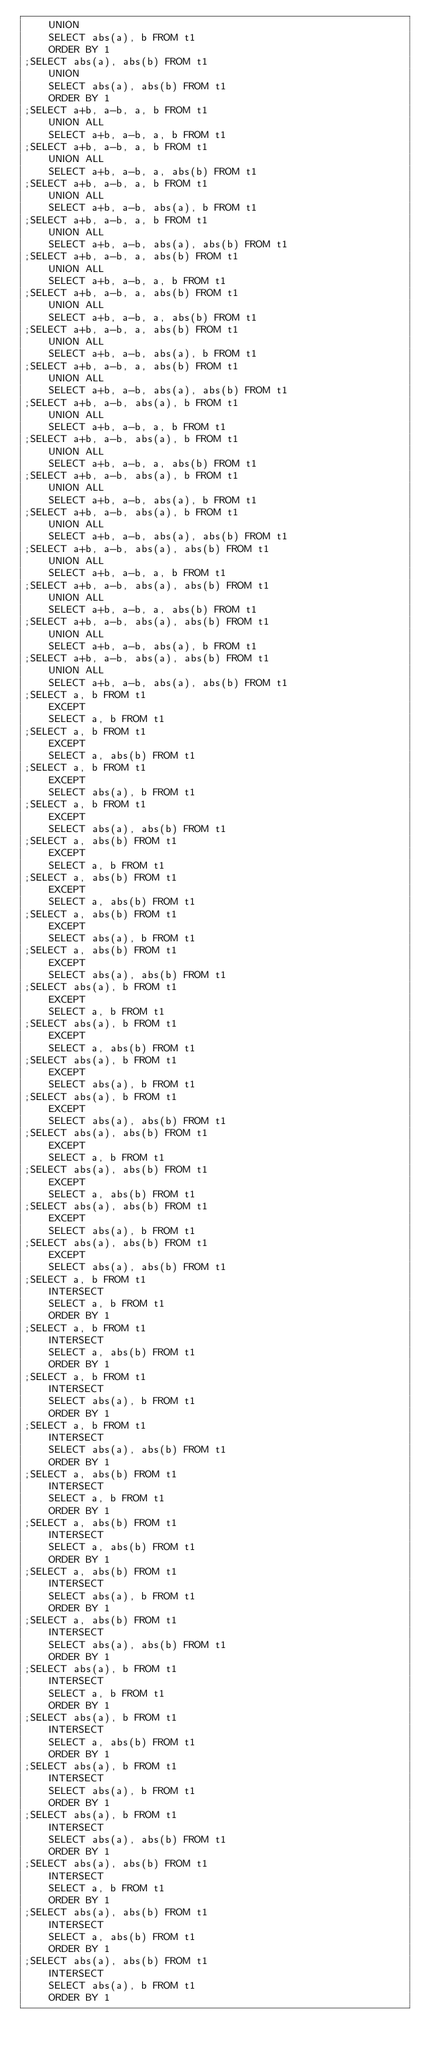Convert code to text. <code><loc_0><loc_0><loc_500><loc_500><_SQL_>    UNION 
    SELECT abs(a), b FROM t1
    ORDER BY 1
;SELECT abs(a), abs(b) FROM t1
    UNION 
    SELECT abs(a), abs(b) FROM t1
    ORDER BY 1
;SELECT a+b, a-b, a, b FROM t1
    UNION ALL
    SELECT a+b, a-b, a, b FROM t1
;SELECT a+b, a-b, a, b FROM t1
    UNION ALL
    SELECT a+b, a-b, a, abs(b) FROM t1
;SELECT a+b, a-b, a, b FROM t1
    UNION ALL
    SELECT a+b, a-b, abs(a), b FROM t1
;SELECT a+b, a-b, a, b FROM t1
    UNION ALL
    SELECT a+b, a-b, abs(a), abs(b) FROM t1
;SELECT a+b, a-b, a, abs(b) FROM t1
    UNION ALL
    SELECT a+b, a-b, a, b FROM t1
;SELECT a+b, a-b, a, abs(b) FROM t1
    UNION ALL
    SELECT a+b, a-b, a, abs(b) FROM t1
;SELECT a+b, a-b, a, abs(b) FROM t1
    UNION ALL
    SELECT a+b, a-b, abs(a), b FROM t1
;SELECT a+b, a-b, a, abs(b) FROM t1
    UNION ALL
    SELECT a+b, a-b, abs(a), abs(b) FROM t1
;SELECT a+b, a-b, abs(a), b FROM t1
    UNION ALL
    SELECT a+b, a-b, a, b FROM t1
;SELECT a+b, a-b, abs(a), b FROM t1
    UNION ALL
    SELECT a+b, a-b, a, abs(b) FROM t1
;SELECT a+b, a-b, abs(a), b FROM t1
    UNION ALL
    SELECT a+b, a-b, abs(a), b FROM t1
;SELECT a+b, a-b, abs(a), b FROM t1
    UNION ALL
    SELECT a+b, a-b, abs(a), abs(b) FROM t1
;SELECT a+b, a-b, abs(a), abs(b) FROM t1
    UNION ALL
    SELECT a+b, a-b, a, b FROM t1
;SELECT a+b, a-b, abs(a), abs(b) FROM t1
    UNION ALL
    SELECT a+b, a-b, a, abs(b) FROM t1
;SELECT a+b, a-b, abs(a), abs(b) FROM t1
    UNION ALL
    SELECT a+b, a-b, abs(a), b FROM t1
;SELECT a+b, a-b, abs(a), abs(b) FROM t1
    UNION ALL
    SELECT a+b, a-b, abs(a), abs(b) FROM t1
;SELECT a, b FROM t1
    EXCEPT
    SELECT a, b FROM t1
;SELECT a, b FROM t1
    EXCEPT
    SELECT a, abs(b) FROM t1
;SELECT a, b FROM t1
    EXCEPT
    SELECT abs(a), b FROM t1
;SELECT a, b FROM t1
    EXCEPT
    SELECT abs(a), abs(b) FROM t1
;SELECT a, abs(b) FROM t1
    EXCEPT
    SELECT a, b FROM t1
;SELECT a, abs(b) FROM t1
    EXCEPT
    SELECT a, abs(b) FROM t1
;SELECT a, abs(b) FROM t1
    EXCEPT
    SELECT abs(a), b FROM t1
;SELECT a, abs(b) FROM t1
    EXCEPT
    SELECT abs(a), abs(b) FROM t1
;SELECT abs(a), b FROM t1
    EXCEPT
    SELECT a, b FROM t1
;SELECT abs(a), b FROM t1
    EXCEPT
    SELECT a, abs(b) FROM t1
;SELECT abs(a), b FROM t1
    EXCEPT
    SELECT abs(a), b FROM t1
;SELECT abs(a), b FROM t1
    EXCEPT
    SELECT abs(a), abs(b) FROM t1
;SELECT abs(a), abs(b) FROM t1
    EXCEPT
    SELECT a, b FROM t1
;SELECT abs(a), abs(b) FROM t1
    EXCEPT
    SELECT a, abs(b) FROM t1
;SELECT abs(a), abs(b) FROM t1
    EXCEPT
    SELECT abs(a), b FROM t1
;SELECT abs(a), abs(b) FROM t1
    EXCEPT
    SELECT abs(a), abs(b) FROM t1
;SELECT a, b FROM t1
    INTERSECT
    SELECT a, b FROM t1
    ORDER BY 1
;SELECT a, b FROM t1
    INTERSECT
    SELECT a, abs(b) FROM t1
    ORDER BY 1
;SELECT a, b FROM t1
    INTERSECT
    SELECT abs(a), b FROM t1
    ORDER BY 1
;SELECT a, b FROM t1
    INTERSECT
    SELECT abs(a), abs(b) FROM t1
    ORDER BY 1
;SELECT a, abs(b) FROM t1
    INTERSECT
    SELECT a, b FROM t1
    ORDER BY 1
;SELECT a, abs(b) FROM t1
    INTERSECT
    SELECT a, abs(b) FROM t1
    ORDER BY 1
;SELECT a, abs(b) FROM t1
    INTERSECT
    SELECT abs(a), b FROM t1
    ORDER BY 1
;SELECT a, abs(b) FROM t1
    INTERSECT
    SELECT abs(a), abs(b) FROM t1
    ORDER BY 1
;SELECT abs(a), b FROM t1
    INTERSECT
    SELECT a, b FROM t1
    ORDER BY 1
;SELECT abs(a), b FROM t1
    INTERSECT
    SELECT a, abs(b) FROM t1
    ORDER BY 1
;SELECT abs(a), b FROM t1
    INTERSECT
    SELECT abs(a), b FROM t1
    ORDER BY 1
;SELECT abs(a), b FROM t1
    INTERSECT
    SELECT abs(a), abs(b) FROM t1
    ORDER BY 1
;SELECT abs(a), abs(b) FROM t1
    INTERSECT
    SELECT a, b FROM t1
    ORDER BY 1
;SELECT abs(a), abs(b) FROM t1
    INTERSECT
    SELECT a, abs(b) FROM t1
    ORDER BY 1
;SELECT abs(a), abs(b) FROM t1
    INTERSECT
    SELECT abs(a), b FROM t1
    ORDER BY 1</code> 